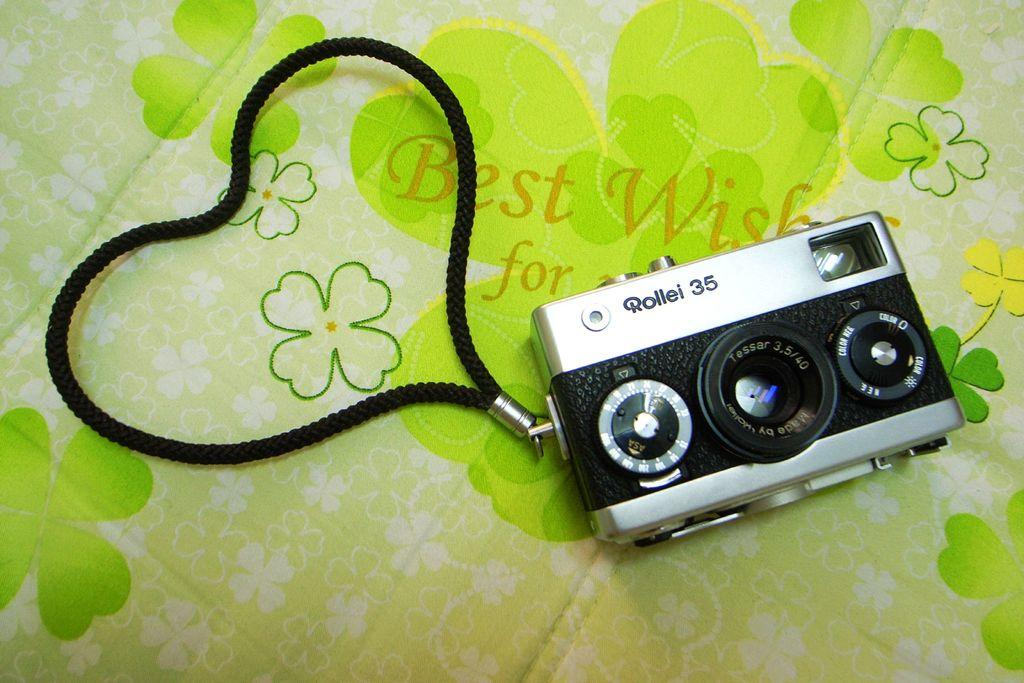<image>
Write a terse but informative summary of the picture. A vintage Rollei 35 camera lays on a piece of cloth with four leaf clovers on it. 